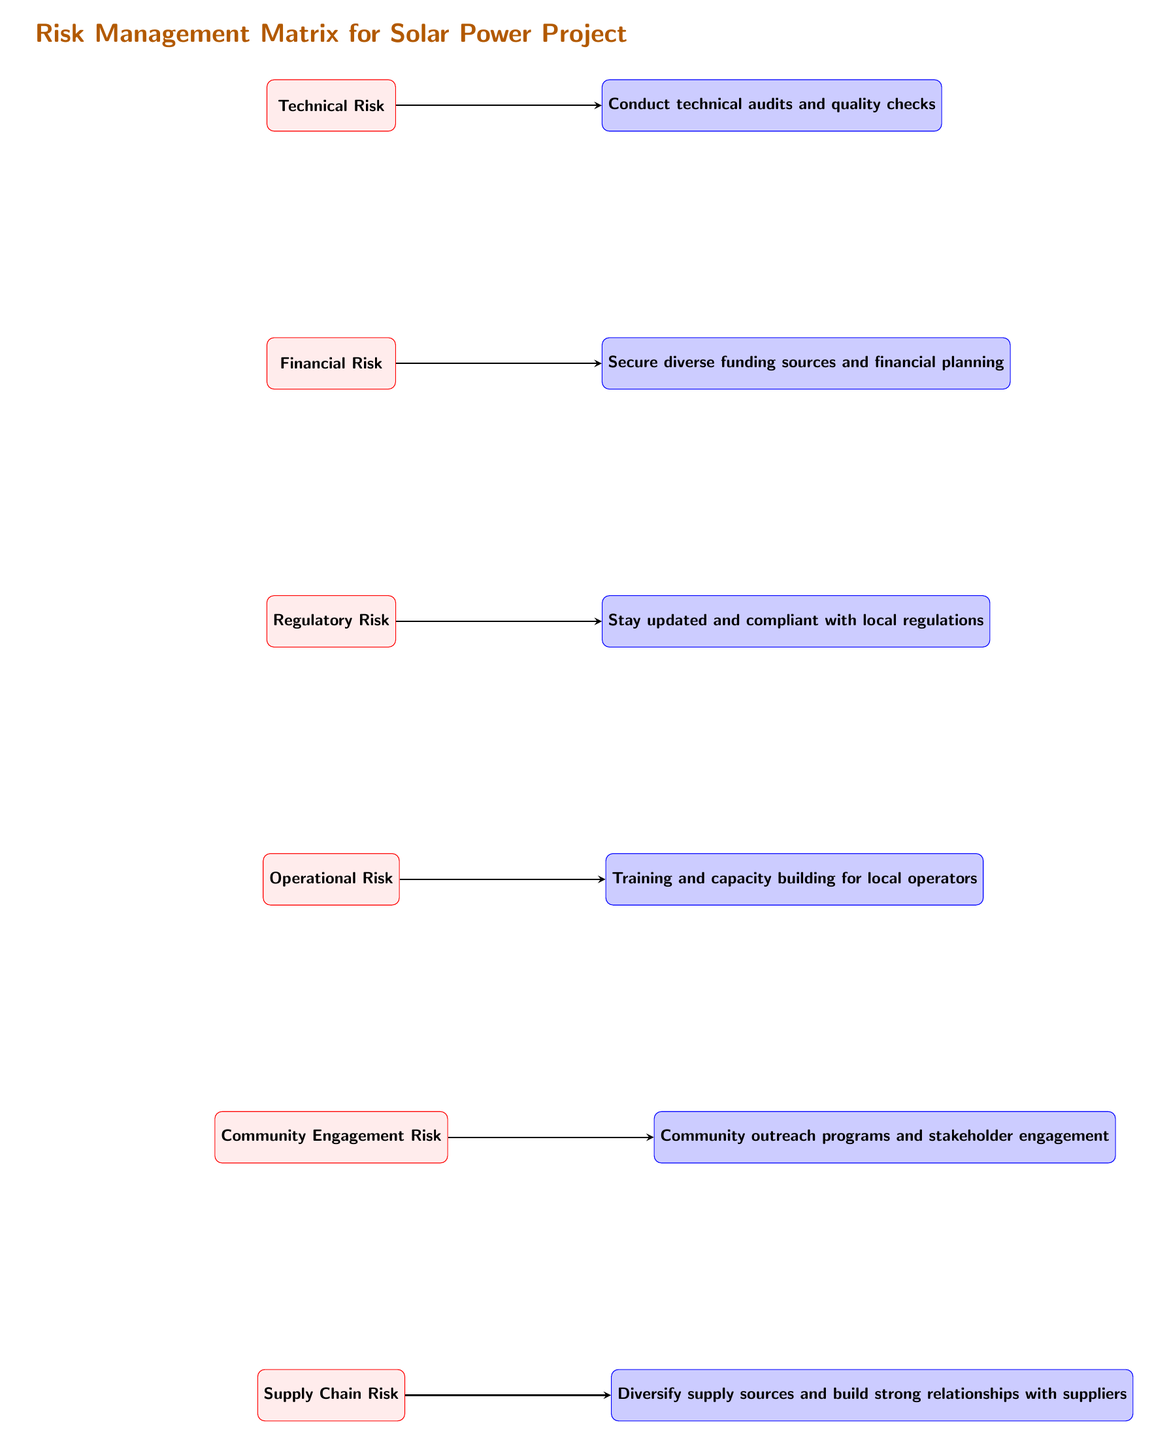What is the first risk listed in the matrix? The first risk node in the matrix is located at the top position among the listed risks. By examining the diagram, the risk stated is "Technical Risk."
Answer: Technical Risk How many risks are identified in this matrix? The matrix contains six risk nodes listed sequentially from top to bottom. Counting each of these nodes confirms the total number of risks as six.
Answer: 6 Which mitigation strategy is associated with Community Engagement Risk? The mitigation strategy directly linked to Community Engagement Risk can be found by following the arrow from the risk node to the corresponding mitigation node. The strategy stated is "Community outreach programs and stakeholder engagement."
Answer: Community outreach programs and stakeholder engagement What is the last risk identified in the diagram? By looking at the sequential arrangement of risk nodes from the top to bottom, the last risk is identified through the bottom position in the list, which indicates "Supply Chain Risk."
Answer: Supply Chain Risk What relationship exists between Financial Risk and its mitigation strategy? Financial Risk has a direct relationship with its mitigation node, which can be established by following the arrow from the Financial Risk node to the corresponding mitigation, indicating that diverse funding sources and financial planning are needed to mitigate this risk.
Answer: Secure diverse funding sources and financial planning What is the main title of the diagram? The title of the diagram is prominently displayed above the risk nodes, clearly indicating the overall focus of the content. The title specifically is "Risk Management Matrix for Solar Power Project."
Answer: Risk Management Matrix for Solar Power Project Which risk has a strategic response that involves technical audits? The strategy involving technical audits pertains to the first risk listed in the matrix. By identifying the arrow that leads to the respective mitigation node, it confirms that the "Technical Risk" requires "Conduct technical audits and quality checks" as a response.
Answer: Conduct technical audits and quality checks Which mitigation strategy is linked to Supply Chain Risk? The mitigation associated with Supply Chain Risk is identified by following its corresponding arrow leading to the mitigation node. The strategy noted is "Diversify supply sources and build strong relationships with suppliers."
Answer: Diversify supply sources and build strong relationships with suppliers 